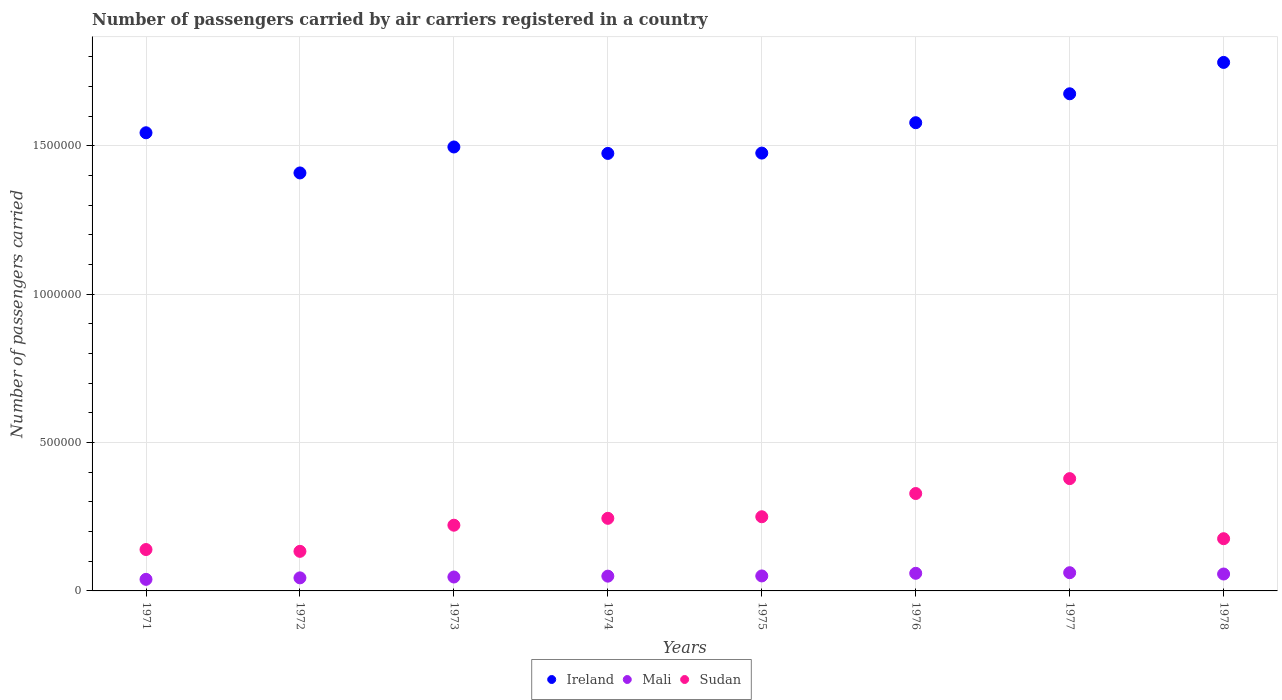How many different coloured dotlines are there?
Provide a succinct answer. 3. Is the number of dotlines equal to the number of legend labels?
Give a very brief answer. Yes. What is the number of passengers carried by air carriers in Sudan in 1977?
Your answer should be very brief. 3.78e+05. Across all years, what is the maximum number of passengers carried by air carriers in Sudan?
Provide a short and direct response. 3.78e+05. Across all years, what is the minimum number of passengers carried by air carriers in Sudan?
Make the answer very short. 1.33e+05. In which year was the number of passengers carried by air carriers in Mali maximum?
Give a very brief answer. 1977. In which year was the number of passengers carried by air carriers in Mali minimum?
Provide a succinct answer. 1971. What is the total number of passengers carried by air carriers in Ireland in the graph?
Your response must be concise. 1.24e+07. What is the difference between the number of passengers carried by air carriers in Ireland in 1976 and that in 1978?
Your answer should be very brief. -2.03e+05. What is the difference between the number of passengers carried by air carriers in Mali in 1973 and the number of passengers carried by air carriers in Sudan in 1977?
Your response must be concise. -3.32e+05. What is the average number of passengers carried by air carriers in Ireland per year?
Your answer should be very brief. 1.55e+06. In the year 1975, what is the difference between the number of passengers carried by air carriers in Sudan and number of passengers carried by air carriers in Mali?
Give a very brief answer. 2.00e+05. What is the ratio of the number of passengers carried by air carriers in Sudan in 1975 to that in 1978?
Make the answer very short. 1.42. What is the difference between the highest and the lowest number of passengers carried by air carriers in Sudan?
Make the answer very short. 2.45e+05. In how many years, is the number of passengers carried by air carriers in Sudan greater than the average number of passengers carried by air carriers in Sudan taken over all years?
Provide a short and direct response. 4. Is the number of passengers carried by air carriers in Sudan strictly less than the number of passengers carried by air carriers in Ireland over the years?
Ensure brevity in your answer.  Yes. Are the values on the major ticks of Y-axis written in scientific E-notation?
Make the answer very short. No. What is the title of the graph?
Offer a very short reply. Number of passengers carried by air carriers registered in a country. Does "Georgia" appear as one of the legend labels in the graph?
Provide a succinct answer. No. What is the label or title of the X-axis?
Your answer should be very brief. Years. What is the label or title of the Y-axis?
Ensure brevity in your answer.  Number of passengers carried. What is the Number of passengers carried in Ireland in 1971?
Your answer should be compact. 1.54e+06. What is the Number of passengers carried in Mali in 1971?
Give a very brief answer. 3.90e+04. What is the Number of passengers carried of Sudan in 1971?
Give a very brief answer. 1.40e+05. What is the Number of passengers carried in Ireland in 1972?
Provide a short and direct response. 1.41e+06. What is the Number of passengers carried in Mali in 1972?
Ensure brevity in your answer.  4.40e+04. What is the Number of passengers carried in Sudan in 1972?
Ensure brevity in your answer.  1.33e+05. What is the Number of passengers carried in Ireland in 1973?
Make the answer very short. 1.50e+06. What is the Number of passengers carried of Mali in 1973?
Your response must be concise. 4.69e+04. What is the Number of passengers carried in Sudan in 1973?
Offer a terse response. 2.22e+05. What is the Number of passengers carried in Ireland in 1974?
Offer a very short reply. 1.47e+06. What is the Number of passengers carried in Mali in 1974?
Your answer should be compact. 4.98e+04. What is the Number of passengers carried in Sudan in 1974?
Your response must be concise. 2.45e+05. What is the Number of passengers carried of Ireland in 1975?
Make the answer very short. 1.48e+06. What is the Number of passengers carried in Mali in 1975?
Provide a short and direct response. 5.05e+04. What is the Number of passengers carried of Ireland in 1976?
Give a very brief answer. 1.58e+06. What is the Number of passengers carried in Mali in 1976?
Offer a very short reply. 5.94e+04. What is the Number of passengers carried of Sudan in 1976?
Provide a short and direct response. 3.28e+05. What is the Number of passengers carried of Ireland in 1977?
Keep it short and to the point. 1.68e+06. What is the Number of passengers carried of Mali in 1977?
Your answer should be very brief. 6.14e+04. What is the Number of passengers carried in Sudan in 1977?
Offer a terse response. 3.78e+05. What is the Number of passengers carried of Ireland in 1978?
Your answer should be compact. 1.78e+06. What is the Number of passengers carried in Mali in 1978?
Keep it short and to the point. 5.70e+04. What is the Number of passengers carried in Sudan in 1978?
Give a very brief answer. 1.76e+05. Across all years, what is the maximum Number of passengers carried of Ireland?
Keep it short and to the point. 1.78e+06. Across all years, what is the maximum Number of passengers carried of Mali?
Offer a very short reply. 6.14e+04. Across all years, what is the maximum Number of passengers carried in Sudan?
Offer a terse response. 3.78e+05. Across all years, what is the minimum Number of passengers carried in Ireland?
Provide a succinct answer. 1.41e+06. Across all years, what is the minimum Number of passengers carried in Mali?
Your answer should be compact. 3.90e+04. Across all years, what is the minimum Number of passengers carried of Sudan?
Provide a short and direct response. 1.33e+05. What is the total Number of passengers carried of Ireland in the graph?
Ensure brevity in your answer.  1.24e+07. What is the total Number of passengers carried in Mali in the graph?
Offer a terse response. 4.08e+05. What is the total Number of passengers carried of Sudan in the graph?
Make the answer very short. 1.87e+06. What is the difference between the Number of passengers carried of Ireland in 1971 and that in 1972?
Offer a very short reply. 1.35e+05. What is the difference between the Number of passengers carried in Mali in 1971 and that in 1972?
Your response must be concise. -5000. What is the difference between the Number of passengers carried of Sudan in 1971 and that in 1972?
Keep it short and to the point. 6100. What is the difference between the Number of passengers carried of Ireland in 1971 and that in 1973?
Keep it short and to the point. 4.79e+04. What is the difference between the Number of passengers carried of Mali in 1971 and that in 1973?
Provide a short and direct response. -7900. What is the difference between the Number of passengers carried in Sudan in 1971 and that in 1973?
Offer a very short reply. -8.20e+04. What is the difference between the Number of passengers carried in Ireland in 1971 and that in 1974?
Keep it short and to the point. 6.96e+04. What is the difference between the Number of passengers carried in Mali in 1971 and that in 1974?
Keep it short and to the point. -1.08e+04. What is the difference between the Number of passengers carried in Sudan in 1971 and that in 1974?
Keep it short and to the point. -1.05e+05. What is the difference between the Number of passengers carried of Ireland in 1971 and that in 1975?
Provide a succinct answer. 6.85e+04. What is the difference between the Number of passengers carried of Mali in 1971 and that in 1975?
Your answer should be compact. -1.15e+04. What is the difference between the Number of passengers carried of Sudan in 1971 and that in 1975?
Ensure brevity in your answer.  -1.10e+05. What is the difference between the Number of passengers carried in Ireland in 1971 and that in 1976?
Your answer should be very brief. -3.39e+04. What is the difference between the Number of passengers carried of Mali in 1971 and that in 1976?
Provide a short and direct response. -2.04e+04. What is the difference between the Number of passengers carried of Sudan in 1971 and that in 1976?
Your response must be concise. -1.89e+05. What is the difference between the Number of passengers carried in Ireland in 1971 and that in 1977?
Make the answer very short. -1.31e+05. What is the difference between the Number of passengers carried in Mali in 1971 and that in 1977?
Ensure brevity in your answer.  -2.24e+04. What is the difference between the Number of passengers carried in Sudan in 1971 and that in 1977?
Give a very brief answer. -2.39e+05. What is the difference between the Number of passengers carried of Ireland in 1971 and that in 1978?
Offer a very short reply. -2.37e+05. What is the difference between the Number of passengers carried of Mali in 1971 and that in 1978?
Your answer should be compact. -1.80e+04. What is the difference between the Number of passengers carried in Sudan in 1971 and that in 1978?
Provide a succinct answer. -3.65e+04. What is the difference between the Number of passengers carried in Ireland in 1972 and that in 1973?
Your answer should be very brief. -8.75e+04. What is the difference between the Number of passengers carried in Mali in 1972 and that in 1973?
Offer a terse response. -2900. What is the difference between the Number of passengers carried of Sudan in 1972 and that in 1973?
Ensure brevity in your answer.  -8.81e+04. What is the difference between the Number of passengers carried of Ireland in 1972 and that in 1974?
Offer a terse response. -6.58e+04. What is the difference between the Number of passengers carried in Mali in 1972 and that in 1974?
Ensure brevity in your answer.  -5800. What is the difference between the Number of passengers carried in Sudan in 1972 and that in 1974?
Offer a very short reply. -1.11e+05. What is the difference between the Number of passengers carried of Ireland in 1972 and that in 1975?
Your response must be concise. -6.69e+04. What is the difference between the Number of passengers carried of Mali in 1972 and that in 1975?
Ensure brevity in your answer.  -6500. What is the difference between the Number of passengers carried of Sudan in 1972 and that in 1975?
Offer a very short reply. -1.17e+05. What is the difference between the Number of passengers carried of Ireland in 1972 and that in 1976?
Keep it short and to the point. -1.69e+05. What is the difference between the Number of passengers carried in Mali in 1972 and that in 1976?
Ensure brevity in your answer.  -1.54e+04. What is the difference between the Number of passengers carried of Sudan in 1972 and that in 1976?
Provide a succinct answer. -1.95e+05. What is the difference between the Number of passengers carried in Ireland in 1972 and that in 1977?
Your answer should be very brief. -2.67e+05. What is the difference between the Number of passengers carried in Mali in 1972 and that in 1977?
Give a very brief answer. -1.74e+04. What is the difference between the Number of passengers carried in Sudan in 1972 and that in 1977?
Provide a short and direct response. -2.45e+05. What is the difference between the Number of passengers carried of Ireland in 1972 and that in 1978?
Make the answer very short. -3.72e+05. What is the difference between the Number of passengers carried of Mali in 1972 and that in 1978?
Your answer should be compact. -1.30e+04. What is the difference between the Number of passengers carried of Sudan in 1972 and that in 1978?
Offer a very short reply. -4.26e+04. What is the difference between the Number of passengers carried of Ireland in 1973 and that in 1974?
Keep it short and to the point. 2.17e+04. What is the difference between the Number of passengers carried of Mali in 1973 and that in 1974?
Keep it short and to the point. -2900. What is the difference between the Number of passengers carried of Sudan in 1973 and that in 1974?
Make the answer very short. -2.32e+04. What is the difference between the Number of passengers carried in Ireland in 1973 and that in 1975?
Give a very brief answer. 2.06e+04. What is the difference between the Number of passengers carried in Mali in 1973 and that in 1975?
Keep it short and to the point. -3600. What is the difference between the Number of passengers carried in Sudan in 1973 and that in 1975?
Offer a very short reply. -2.85e+04. What is the difference between the Number of passengers carried of Ireland in 1973 and that in 1976?
Give a very brief answer. -8.18e+04. What is the difference between the Number of passengers carried in Mali in 1973 and that in 1976?
Make the answer very short. -1.25e+04. What is the difference between the Number of passengers carried in Sudan in 1973 and that in 1976?
Offer a terse response. -1.07e+05. What is the difference between the Number of passengers carried of Ireland in 1973 and that in 1977?
Provide a succinct answer. -1.79e+05. What is the difference between the Number of passengers carried of Mali in 1973 and that in 1977?
Offer a very short reply. -1.45e+04. What is the difference between the Number of passengers carried in Sudan in 1973 and that in 1977?
Your answer should be very brief. -1.57e+05. What is the difference between the Number of passengers carried of Ireland in 1973 and that in 1978?
Keep it short and to the point. -2.85e+05. What is the difference between the Number of passengers carried of Mali in 1973 and that in 1978?
Keep it short and to the point. -1.01e+04. What is the difference between the Number of passengers carried in Sudan in 1973 and that in 1978?
Make the answer very short. 4.55e+04. What is the difference between the Number of passengers carried in Ireland in 1974 and that in 1975?
Provide a succinct answer. -1100. What is the difference between the Number of passengers carried of Mali in 1974 and that in 1975?
Your answer should be very brief. -700. What is the difference between the Number of passengers carried in Sudan in 1974 and that in 1975?
Your answer should be compact. -5300. What is the difference between the Number of passengers carried of Ireland in 1974 and that in 1976?
Provide a short and direct response. -1.04e+05. What is the difference between the Number of passengers carried of Mali in 1974 and that in 1976?
Your answer should be compact. -9600. What is the difference between the Number of passengers carried in Sudan in 1974 and that in 1976?
Make the answer very short. -8.36e+04. What is the difference between the Number of passengers carried of Ireland in 1974 and that in 1977?
Make the answer very short. -2.01e+05. What is the difference between the Number of passengers carried in Mali in 1974 and that in 1977?
Offer a terse response. -1.16e+04. What is the difference between the Number of passengers carried of Sudan in 1974 and that in 1977?
Offer a very short reply. -1.34e+05. What is the difference between the Number of passengers carried of Ireland in 1974 and that in 1978?
Your response must be concise. -3.07e+05. What is the difference between the Number of passengers carried of Mali in 1974 and that in 1978?
Provide a short and direct response. -7200. What is the difference between the Number of passengers carried in Sudan in 1974 and that in 1978?
Your answer should be compact. 6.87e+04. What is the difference between the Number of passengers carried in Ireland in 1975 and that in 1976?
Your answer should be compact. -1.02e+05. What is the difference between the Number of passengers carried of Mali in 1975 and that in 1976?
Offer a very short reply. -8900. What is the difference between the Number of passengers carried of Sudan in 1975 and that in 1976?
Give a very brief answer. -7.83e+04. What is the difference between the Number of passengers carried of Ireland in 1975 and that in 1977?
Your answer should be compact. -2.00e+05. What is the difference between the Number of passengers carried in Mali in 1975 and that in 1977?
Keep it short and to the point. -1.09e+04. What is the difference between the Number of passengers carried in Sudan in 1975 and that in 1977?
Your answer should be compact. -1.28e+05. What is the difference between the Number of passengers carried of Ireland in 1975 and that in 1978?
Provide a succinct answer. -3.06e+05. What is the difference between the Number of passengers carried in Mali in 1975 and that in 1978?
Your response must be concise. -6500. What is the difference between the Number of passengers carried in Sudan in 1975 and that in 1978?
Offer a terse response. 7.40e+04. What is the difference between the Number of passengers carried of Ireland in 1976 and that in 1977?
Ensure brevity in your answer.  -9.75e+04. What is the difference between the Number of passengers carried in Mali in 1976 and that in 1977?
Offer a very short reply. -2000. What is the difference between the Number of passengers carried in Sudan in 1976 and that in 1977?
Ensure brevity in your answer.  -5.02e+04. What is the difference between the Number of passengers carried of Ireland in 1976 and that in 1978?
Ensure brevity in your answer.  -2.03e+05. What is the difference between the Number of passengers carried of Mali in 1976 and that in 1978?
Keep it short and to the point. 2400. What is the difference between the Number of passengers carried of Sudan in 1976 and that in 1978?
Your answer should be compact. 1.52e+05. What is the difference between the Number of passengers carried in Ireland in 1977 and that in 1978?
Your response must be concise. -1.06e+05. What is the difference between the Number of passengers carried in Mali in 1977 and that in 1978?
Offer a terse response. 4400. What is the difference between the Number of passengers carried in Sudan in 1977 and that in 1978?
Offer a terse response. 2.02e+05. What is the difference between the Number of passengers carried in Ireland in 1971 and the Number of passengers carried in Mali in 1972?
Provide a succinct answer. 1.50e+06. What is the difference between the Number of passengers carried in Ireland in 1971 and the Number of passengers carried in Sudan in 1972?
Your answer should be compact. 1.41e+06. What is the difference between the Number of passengers carried of Mali in 1971 and the Number of passengers carried of Sudan in 1972?
Your answer should be compact. -9.44e+04. What is the difference between the Number of passengers carried of Ireland in 1971 and the Number of passengers carried of Mali in 1973?
Ensure brevity in your answer.  1.50e+06. What is the difference between the Number of passengers carried of Ireland in 1971 and the Number of passengers carried of Sudan in 1973?
Offer a very short reply. 1.32e+06. What is the difference between the Number of passengers carried in Mali in 1971 and the Number of passengers carried in Sudan in 1973?
Offer a very short reply. -1.82e+05. What is the difference between the Number of passengers carried of Ireland in 1971 and the Number of passengers carried of Mali in 1974?
Your response must be concise. 1.49e+06. What is the difference between the Number of passengers carried of Ireland in 1971 and the Number of passengers carried of Sudan in 1974?
Ensure brevity in your answer.  1.30e+06. What is the difference between the Number of passengers carried of Mali in 1971 and the Number of passengers carried of Sudan in 1974?
Your response must be concise. -2.06e+05. What is the difference between the Number of passengers carried in Ireland in 1971 and the Number of passengers carried in Mali in 1975?
Keep it short and to the point. 1.49e+06. What is the difference between the Number of passengers carried in Ireland in 1971 and the Number of passengers carried in Sudan in 1975?
Provide a succinct answer. 1.29e+06. What is the difference between the Number of passengers carried of Mali in 1971 and the Number of passengers carried of Sudan in 1975?
Offer a terse response. -2.11e+05. What is the difference between the Number of passengers carried of Ireland in 1971 and the Number of passengers carried of Mali in 1976?
Offer a terse response. 1.48e+06. What is the difference between the Number of passengers carried of Ireland in 1971 and the Number of passengers carried of Sudan in 1976?
Offer a very short reply. 1.22e+06. What is the difference between the Number of passengers carried of Mali in 1971 and the Number of passengers carried of Sudan in 1976?
Provide a short and direct response. -2.89e+05. What is the difference between the Number of passengers carried of Ireland in 1971 and the Number of passengers carried of Mali in 1977?
Provide a short and direct response. 1.48e+06. What is the difference between the Number of passengers carried of Ireland in 1971 and the Number of passengers carried of Sudan in 1977?
Your response must be concise. 1.17e+06. What is the difference between the Number of passengers carried of Mali in 1971 and the Number of passengers carried of Sudan in 1977?
Give a very brief answer. -3.40e+05. What is the difference between the Number of passengers carried of Ireland in 1971 and the Number of passengers carried of Mali in 1978?
Your answer should be very brief. 1.49e+06. What is the difference between the Number of passengers carried of Ireland in 1971 and the Number of passengers carried of Sudan in 1978?
Your answer should be compact. 1.37e+06. What is the difference between the Number of passengers carried in Mali in 1971 and the Number of passengers carried in Sudan in 1978?
Your answer should be compact. -1.37e+05. What is the difference between the Number of passengers carried of Ireland in 1972 and the Number of passengers carried of Mali in 1973?
Your response must be concise. 1.36e+06. What is the difference between the Number of passengers carried of Ireland in 1972 and the Number of passengers carried of Sudan in 1973?
Your answer should be very brief. 1.19e+06. What is the difference between the Number of passengers carried in Mali in 1972 and the Number of passengers carried in Sudan in 1973?
Your answer should be compact. -1.78e+05. What is the difference between the Number of passengers carried in Ireland in 1972 and the Number of passengers carried in Mali in 1974?
Keep it short and to the point. 1.36e+06. What is the difference between the Number of passengers carried of Ireland in 1972 and the Number of passengers carried of Sudan in 1974?
Keep it short and to the point. 1.16e+06. What is the difference between the Number of passengers carried of Mali in 1972 and the Number of passengers carried of Sudan in 1974?
Ensure brevity in your answer.  -2.01e+05. What is the difference between the Number of passengers carried in Ireland in 1972 and the Number of passengers carried in Mali in 1975?
Your answer should be compact. 1.36e+06. What is the difference between the Number of passengers carried in Ireland in 1972 and the Number of passengers carried in Sudan in 1975?
Offer a very short reply. 1.16e+06. What is the difference between the Number of passengers carried of Mali in 1972 and the Number of passengers carried of Sudan in 1975?
Give a very brief answer. -2.06e+05. What is the difference between the Number of passengers carried of Ireland in 1972 and the Number of passengers carried of Mali in 1976?
Your answer should be compact. 1.35e+06. What is the difference between the Number of passengers carried of Ireland in 1972 and the Number of passengers carried of Sudan in 1976?
Offer a very short reply. 1.08e+06. What is the difference between the Number of passengers carried in Mali in 1972 and the Number of passengers carried in Sudan in 1976?
Make the answer very short. -2.84e+05. What is the difference between the Number of passengers carried in Ireland in 1972 and the Number of passengers carried in Mali in 1977?
Provide a short and direct response. 1.35e+06. What is the difference between the Number of passengers carried of Ireland in 1972 and the Number of passengers carried of Sudan in 1977?
Provide a succinct answer. 1.03e+06. What is the difference between the Number of passengers carried of Mali in 1972 and the Number of passengers carried of Sudan in 1977?
Your answer should be compact. -3.34e+05. What is the difference between the Number of passengers carried in Ireland in 1972 and the Number of passengers carried in Mali in 1978?
Make the answer very short. 1.35e+06. What is the difference between the Number of passengers carried in Ireland in 1972 and the Number of passengers carried in Sudan in 1978?
Provide a short and direct response. 1.23e+06. What is the difference between the Number of passengers carried of Mali in 1972 and the Number of passengers carried of Sudan in 1978?
Make the answer very short. -1.32e+05. What is the difference between the Number of passengers carried in Ireland in 1973 and the Number of passengers carried in Mali in 1974?
Offer a very short reply. 1.45e+06. What is the difference between the Number of passengers carried of Ireland in 1973 and the Number of passengers carried of Sudan in 1974?
Provide a succinct answer. 1.25e+06. What is the difference between the Number of passengers carried in Mali in 1973 and the Number of passengers carried in Sudan in 1974?
Your answer should be very brief. -1.98e+05. What is the difference between the Number of passengers carried in Ireland in 1973 and the Number of passengers carried in Mali in 1975?
Your response must be concise. 1.45e+06. What is the difference between the Number of passengers carried of Ireland in 1973 and the Number of passengers carried of Sudan in 1975?
Provide a short and direct response. 1.25e+06. What is the difference between the Number of passengers carried in Mali in 1973 and the Number of passengers carried in Sudan in 1975?
Your answer should be compact. -2.03e+05. What is the difference between the Number of passengers carried of Ireland in 1973 and the Number of passengers carried of Mali in 1976?
Make the answer very short. 1.44e+06. What is the difference between the Number of passengers carried of Ireland in 1973 and the Number of passengers carried of Sudan in 1976?
Ensure brevity in your answer.  1.17e+06. What is the difference between the Number of passengers carried of Mali in 1973 and the Number of passengers carried of Sudan in 1976?
Your answer should be compact. -2.81e+05. What is the difference between the Number of passengers carried of Ireland in 1973 and the Number of passengers carried of Mali in 1977?
Give a very brief answer. 1.43e+06. What is the difference between the Number of passengers carried in Ireland in 1973 and the Number of passengers carried in Sudan in 1977?
Give a very brief answer. 1.12e+06. What is the difference between the Number of passengers carried of Mali in 1973 and the Number of passengers carried of Sudan in 1977?
Provide a succinct answer. -3.32e+05. What is the difference between the Number of passengers carried of Ireland in 1973 and the Number of passengers carried of Mali in 1978?
Give a very brief answer. 1.44e+06. What is the difference between the Number of passengers carried of Ireland in 1973 and the Number of passengers carried of Sudan in 1978?
Offer a terse response. 1.32e+06. What is the difference between the Number of passengers carried in Mali in 1973 and the Number of passengers carried in Sudan in 1978?
Provide a short and direct response. -1.29e+05. What is the difference between the Number of passengers carried of Ireland in 1974 and the Number of passengers carried of Mali in 1975?
Make the answer very short. 1.42e+06. What is the difference between the Number of passengers carried of Ireland in 1974 and the Number of passengers carried of Sudan in 1975?
Your answer should be very brief. 1.22e+06. What is the difference between the Number of passengers carried of Mali in 1974 and the Number of passengers carried of Sudan in 1975?
Ensure brevity in your answer.  -2.00e+05. What is the difference between the Number of passengers carried of Ireland in 1974 and the Number of passengers carried of Mali in 1976?
Make the answer very short. 1.42e+06. What is the difference between the Number of passengers carried in Ireland in 1974 and the Number of passengers carried in Sudan in 1976?
Make the answer very short. 1.15e+06. What is the difference between the Number of passengers carried of Mali in 1974 and the Number of passengers carried of Sudan in 1976?
Provide a short and direct response. -2.78e+05. What is the difference between the Number of passengers carried in Ireland in 1974 and the Number of passengers carried in Mali in 1977?
Keep it short and to the point. 1.41e+06. What is the difference between the Number of passengers carried in Ireland in 1974 and the Number of passengers carried in Sudan in 1977?
Your answer should be compact. 1.10e+06. What is the difference between the Number of passengers carried in Mali in 1974 and the Number of passengers carried in Sudan in 1977?
Make the answer very short. -3.29e+05. What is the difference between the Number of passengers carried of Ireland in 1974 and the Number of passengers carried of Mali in 1978?
Offer a terse response. 1.42e+06. What is the difference between the Number of passengers carried in Ireland in 1974 and the Number of passengers carried in Sudan in 1978?
Make the answer very short. 1.30e+06. What is the difference between the Number of passengers carried in Mali in 1974 and the Number of passengers carried in Sudan in 1978?
Offer a very short reply. -1.26e+05. What is the difference between the Number of passengers carried of Ireland in 1975 and the Number of passengers carried of Mali in 1976?
Make the answer very short. 1.42e+06. What is the difference between the Number of passengers carried of Ireland in 1975 and the Number of passengers carried of Sudan in 1976?
Offer a terse response. 1.15e+06. What is the difference between the Number of passengers carried in Mali in 1975 and the Number of passengers carried in Sudan in 1976?
Give a very brief answer. -2.78e+05. What is the difference between the Number of passengers carried in Ireland in 1975 and the Number of passengers carried in Mali in 1977?
Your response must be concise. 1.41e+06. What is the difference between the Number of passengers carried of Ireland in 1975 and the Number of passengers carried of Sudan in 1977?
Provide a succinct answer. 1.10e+06. What is the difference between the Number of passengers carried of Mali in 1975 and the Number of passengers carried of Sudan in 1977?
Make the answer very short. -3.28e+05. What is the difference between the Number of passengers carried in Ireland in 1975 and the Number of passengers carried in Mali in 1978?
Your answer should be compact. 1.42e+06. What is the difference between the Number of passengers carried in Ireland in 1975 and the Number of passengers carried in Sudan in 1978?
Keep it short and to the point. 1.30e+06. What is the difference between the Number of passengers carried of Mali in 1975 and the Number of passengers carried of Sudan in 1978?
Your answer should be very brief. -1.26e+05. What is the difference between the Number of passengers carried in Ireland in 1976 and the Number of passengers carried in Mali in 1977?
Ensure brevity in your answer.  1.52e+06. What is the difference between the Number of passengers carried of Ireland in 1976 and the Number of passengers carried of Sudan in 1977?
Your response must be concise. 1.20e+06. What is the difference between the Number of passengers carried in Mali in 1976 and the Number of passengers carried in Sudan in 1977?
Provide a succinct answer. -3.19e+05. What is the difference between the Number of passengers carried in Ireland in 1976 and the Number of passengers carried in Mali in 1978?
Offer a very short reply. 1.52e+06. What is the difference between the Number of passengers carried in Ireland in 1976 and the Number of passengers carried in Sudan in 1978?
Offer a very short reply. 1.40e+06. What is the difference between the Number of passengers carried in Mali in 1976 and the Number of passengers carried in Sudan in 1978?
Your answer should be very brief. -1.17e+05. What is the difference between the Number of passengers carried in Ireland in 1977 and the Number of passengers carried in Mali in 1978?
Provide a succinct answer. 1.62e+06. What is the difference between the Number of passengers carried of Ireland in 1977 and the Number of passengers carried of Sudan in 1978?
Provide a short and direct response. 1.50e+06. What is the difference between the Number of passengers carried of Mali in 1977 and the Number of passengers carried of Sudan in 1978?
Provide a succinct answer. -1.15e+05. What is the average Number of passengers carried in Ireland per year?
Make the answer very short. 1.55e+06. What is the average Number of passengers carried of Mali per year?
Your response must be concise. 5.10e+04. What is the average Number of passengers carried in Sudan per year?
Make the answer very short. 2.34e+05. In the year 1971, what is the difference between the Number of passengers carried of Ireland and Number of passengers carried of Mali?
Keep it short and to the point. 1.51e+06. In the year 1971, what is the difference between the Number of passengers carried of Ireland and Number of passengers carried of Sudan?
Ensure brevity in your answer.  1.40e+06. In the year 1971, what is the difference between the Number of passengers carried in Mali and Number of passengers carried in Sudan?
Offer a terse response. -1.00e+05. In the year 1972, what is the difference between the Number of passengers carried of Ireland and Number of passengers carried of Mali?
Make the answer very short. 1.36e+06. In the year 1972, what is the difference between the Number of passengers carried of Ireland and Number of passengers carried of Sudan?
Make the answer very short. 1.28e+06. In the year 1972, what is the difference between the Number of passengers carried of Mali and Number of passengers carried of Sudan?
Make the answer very short. -8.94e+04. In the year 1973, what is the difference between the Number of passengers carried in Ireland and Number of passengers carried in Mali?
Make the answer very short. 1.45e+06. In the year 1973, what is the difference between the Number of passengers carried in Ireland and Number of passengers carried in Sudan?
Offer a terse response. 1.27e+06. In the year 1973, what is the difference between the Number of passengers carried in Mali and Number of passengers carried in Sudan?
Your answer should be compact. -1.75e+05. In the year 1974, what is the difference between the Number of passengers carried of Ireland and Number of passengers carried of Mali?
Give a very brief answer. 1.42e+06. In the year 1974, what is the difference between the Number of passengers carried in Ireland and Number of passengers carried in Sudan?
Offer a very short reply. 1.23e+06. In the year 1974, what is the difference between the Number of passengers carried of Mali and Number of passengers carried of Sudan?
Your response must be concise. -1.95e+05. In the year 1975, what is the difference between the Number of passengers carried in Ireland and Number of passengers carried in Mali?
Offer a very short reply. 1.43e+06. In the year 1975, what is the difference between the Number of passengers carried of Ireland and Number of passengers carried of Sudan?
Give a very brief answer. 1.23e+06. In the year 1975, what is the difference between the Number of passengers carried in Mali and Number of passengers carried in Sudan?
Offer a very short reply. -2.00e+05. In the year 1976, what is the difference between the Number of passengers carried of Ireland and Number of passengers carried of Mali?
Your response must be concise. 1.52e+06. In the year 1976, what is the difference between the Number of passengers carried in Ireland and Number of passengers carried in Sudan?
Your response must be concise. 1.25e+06. In the year 1976, what is the difference between the Number of passengers carried of Mali and Number of passengers carried of Sudan?
Your response must be concise. -2.69e+05. In the year 1977, what is the difference between the Number of passengers carried in Ireland and Number of passengers carried in Mali?
Make the answer very short. 1.61e+06. In the year 1977, what is the difference between the Number of passengers carried of Ireland and Number of passengers carried of Sudan?
Ensure brevity in your answer.  1.30e+06. In the year 1977, what is the difference between the Number of passengers carried in Mali and Number of passengers carried in Sudan?
Offer a terse response. -3.17e+05. In the year 1978, what is the difference between the Number of passengers carried in Ireland and Number of passengers carried in Mali?
Your answer should be very brief. 1.72e+06. In the year 1978, what is the difference between the Number of passengers carried in Ireland and Number of passengers carried in Sudan?
Offer a terse response. 1.61e+06. In the year 1978, what is the difference between the Number of passengers carried of Mali and Number of passengers carried of Sudan?
Your response must be concise. -1.19e+05. What is the ratio of the Number of passengers carried of Ireland in 1971 to that in 1972?
Give a very brief answer. 1.1. What is the ratio of the Number of passengers carried of Mali in 1971 to that in 1972?
Provide a short and direct response. 0.89. What is the ratio of the Number of passengers carried of Sudan in 1971 to that in 1972?
Provide a succinct answer. 1.05. What is the ratio of the Number of passengers carried in Ireland in 1971 to that in 1973?
Offer a terse response. 1.03. What is the ratio of the Number of passengers carried in Mali in 1971 to that in 1973?
Offer a terse response. 0.83. What is the ratio of the Number of passengers carried in Sudan in 1971 to that in 1973?
Provide a succinct answer. 0.63. What is the ratio of the Number of passengers carried of Ireland in 1971 to that in 1974?
Your answer should be compact. 1.05. What is the ratio of the Number of passengers carried in Mali in 1971 to that in 1974?
Provide a short and direct response. 0.78. What is the ratio of the Number of passengers carried in Sudan in 1971 to that in 1974?
Provide a succinct answer. 0.57. What is the ratio of the Number of passengers carried in Ireland in 1971 to that in 1975?
Your answer should be compact. 1.05. What is the ratio of the Number of passengers carried in Mali in 1971 to that in 1975?
Your answer should be very brief. 0.77. What is the ratio of the Number of passengers carried of Sudan in 1971 to that in 1975?
Your response must be concise. 0.56. What is the ratio of the Number of passengers carried of Ireland in 1971 to that in 1976?
Your answer should be very brief. 0.98. What is the ratio of the Number of passengers carried of Mali in 1971 to that in 1976?
Make the answer very short. 0.66. What is the ratio of the Number of passengers carried in Sudan in 1971 to that in 1976?
Offer a very short reply. 0.42. What is the ratio of the Number of passengers carried of Ireland in 1971 to that in 1977?
Your answer should be compact. 0.92. What is the ratio of the Number of passengers carried in Mali in 1971 to that in 1977?
Your response must be concise. 0.64. What is the ratio of the Number of passengers carried in Sudan in 1971 to that in 1977?
Keep it short and to the point. 0.37. What is the ratio of the Number of passengers carried of Ireland in 1971 to that in 1978?
Provide a short and direct response. 0.87. What is the ratio of the Number of passengers carried of Mali in 1971 to that in 1978?
Make the answer very short. 0.68. What is the ratio of the Number of passengers carried of Sudan in 1971 to that in 1978?
Your response must be concise. 0.79. What is the ratio of the Number of passengers carried in Ireland in 1972 to that in 1973?
Provide a succinct answer. 0.94. What is the ratio of the Number of passengers carried in Mali in 1972 to that in 1973?
Make the answer very short. 0.94. What is the ratio of the Number of passengers carried in Sudan in 1972 to that in 1973?
Your answer should be very brief. 0.6. What is the ratio of the Number of passengers carried of Ireland in 1972 to that in 1974?
Ensure brevity in your answer.  0.96. What is the ratio of the Number of passengers carried of Mali in 1972 to that in 1974?
Provide a short and direct response. 0.88. What is the ratio of the Number of passengers carried in Sudan in 1972 to that in 1974?
Provide a succinct answer. 0.55. What is the ratio of the Number of passengers carried in Ireland in 1972 to that in 1975?
Keep it short and to the point. 0.95. What is the ratio of the Number of passengers carried in Mali in 1972 to that in 1975?
Make the answer very short. 0.87. What is the ratio of the Number of passengers carried in Sudan in 1972 to that in 1975?
Keep it short and to the point. 0.53. What is the ratio of the Number of passengers carried of Ireland in 1972 to that in 1976?
Provide a short and direct response. 0.89. What is the ratio of the Number of passengers carried in Mali in 1972 to that in 1976?
Your answer should be very brief. 0.74. What is the ratio of the Number of passengers carried of Sudan in 1972 to that in 1976?
Give a very brief answer. 0.41. What is the ratio of the Number of passengers carried in Ireland in 1972 to that in 1977?
Your answer should be compact. 0.84. What is the ratio of the Number of passengers carried of Mali in 1972 to that in 1977?
Offer a very short reply. 0.72. What is the ratio of the Number of passengers carried in Sudan in 1972 to that in 1977?
Give a very brief answer. 0.35. What is the ratio of the Number of passengers carried in Ireland in 1972 to that in 1978?
Keep it short and to the point. 0.79. What is the ratio of the Number of passengers carried of Mali in 1972 to that in 1978?
Ensure brevity in your answer.  0.77. What is the ratio of the Number of passengers carried in Sudan in 1972 to that in 1978?
Provide a succinct answer. 0.76. What is the ratio of the Number of passengers carried in Ireland in 1973 to that in 1974?
Offer a very short reply. 1.01. What is the ratio of the Number of passengers carried of Mali in 1973 to that in 1974?
Provide a short and direct response. 0.94. What is the ratio of the Number of passengers carried in Sudan in 1973 to that in 1974?
Ensure brevity in your answer.  0.91. What is the ratio of the Number of passengers carried in Ireland in 1973 to that in 1975?
Keep it short and to the point. 1.01. What is the ratio of the Number of passengers carried in Mali in 1973 to that in 1975?
Ensure brevity in your answer.  0.93. What is the ratio of the Number of passengers carried in Sudan in 1973 to that in 1975?
Ensure brevity in your answer.  0.89. What is the ratio of the Number of passengers carried of Ireland in 1973 to that in 1976?
Make the answer very short. 0.95. What is the ratio of the Number of passengers carried of Mali in 1973 to that in 1976?
Keep it short and to the point. 0.79. What is the ratio of the Number of passengers carried in Sudan in 1973 to that in 1976?
Make the answer very short. 0.67. What is the ratio of the Number of passengers carried of Ireland in 1973 to that in 1977?
Provide a short and direct response. 0.89. What is the ratio of the Number of passengers carried in Mali in 1973 to that in 1977?
Make the answer very short. 0.76. What is the ratio of the Number of passengers carried in Sudan in 1973 to that in 1977?
Offer a terse response. 0.59. What is the ratio of the Number of passengers carried in Ireland in 1973 to that in 1978?
Your answer should be compact. 0.84. What is the ratio of the Number of passengers carried in Mali in 1973 to that in 1978?
Your answer should be very brief. 0.82. What is the ratio of the Number of passengers carried of Sudan in 1973 to that in 1978?
Provide a succinct answer. 1.26. What is the ratio of the Number of passengers carried in Ireland in 1974 to that in 1975?
Your answer should be compact. 1. What is the ratio of the Number of passengers carried in Mali in 1974 to that in 1975?
Your answer should be compact. 0.99. What is the ratio of the Number of passengers carried of Sudan in 1974 to that in 1975?
Your answer should be very brief. 0.98. What is the ratio of the Number of passengers carried in Ireland in 1974 to that in 1976?
Offer a very short reply. 0.93. What is the ratio of the Number of passengers carried in Mali in 1974 to that in 1976?
Make the answer very short. 0.84. What is the ratio of the Number of passengers carried of Sudan in 1974 to that in 1976?
Make the answer very short. 0.75. What is the ratio of the Number of passengers carried in Mali in 1974 to that in 1977?
Your response must be concise. 0.81. What is the ratio of the Number of passengers carried of Sudan in 1974 to that in 1977?
Provide a succinct answer. 0.65. What is the ratio of the Number of passengers carried in Ireland in 1974 to that in 1978?
Make the answer very short. 0.83. What is the ratio of the Number of passengers carried in Mali in 1974 to that in 1978?
Your response must be concise. 0.87. What is the ratio of the Number of passengers carried in Sudan in 1974 to that in 1978?
Ensure brevity in your answer.  1.39. What is the ratio of the Number of passengers carried in Ireland in 1975 to that in 1976?
Your response must be concise. 0.94. What is the ratio of the Number of passengers carried of Mali in 1975 to that in 1976?
Make the answer very short. 0.85. What is the ratio of the Number of passengers carried in Sudan in 1975 to that in 1976?
Ensure brevity in your answer.  0.76. What is the ratio of the Number of passengers carried of Ireland in 1975 to that in 1977?
Ensure brevity in your answer.  0.88. What is the ratio of the Number of passengers carried in Mali in 1975 to that in 1977?
Offer a very short reply. 0.82. What is the ratio of the Number of passengers carried of Sudan in 1975 to that in 1977?
Ensure brevity in your answer.  0.66. What is the ratio of the Number of passengers carried of Ireland in 1975 to that in 1978?
Your response must be concise. 0.83. What is the ratio of the Number of passengers carried in Mali in 1975 to that in 1978?
Provide a succinct answer. 0.89. What is the ratio of the Number of passengers carried in Sudan in 1975 to that in 1978?
Keep it short and to the point. 1.42. What is the ratio of the Number of passengers carried in Ireland in 1976 to that in 1977?
Your answer should be very brief. 0.94. What is the ratio of the Number of passengers carried in Mali in 1976 to that in 1977?
Give a very brief answer. 0.97. What is the ratio of the Number of passengers carried of Sudan in 1976 to that in 1977?
Provide a short and direct response. 0.87. What is the ratio of the Number of passengers carried in Ireland in 1976 to that in 1978?
Offer a very short reply. 0.89. What is the ratio of the Number of passengers carried of Mali in 1976 to that in 1978?
Offer a terse response. 1.04. What is the ratio of the Number of passengers carried in Sudan in 1976 to that in 1978?
Offer a very short reply. 1.87. What is the ratio of the Number of passengers carried of Ireland in 1977 to that in 1978?
Your response must be concise. 0.94. What is the ratio of the Number of passengers carried in Mali in 1977 to that in 1978?
Provide a short and direct response. 1.08. What is the ratio of the Number of passengers carried in Sudan in 1977 to that in 1978?
Your answer should be very brief. 2.15. What is the difference between the highest and the second highest Number of passengers carried of Ireland?
Keep it short and to the point. 1.06e+05. What is the difference between the highest and the second highest Number of passengers carried in Mali?
Make the answer very short. 2000. What is the difference between the highest and the second highest Number of passengers carried of Sudan?
Your answer should be compact. 5.02e+04. What is the difference between the highest and the lowest Number of passengers carried of Ireland?
Offer a very short reply. 3.72e+05. What is the difference between the highest and the lowest Number of passengers carried in Mali?
Offer a very short reply. 2.24e+04. What is the difference between the highest and the lowest Number of passengers carried in Sudan?
Offer a terse response. 2.45e+05. 